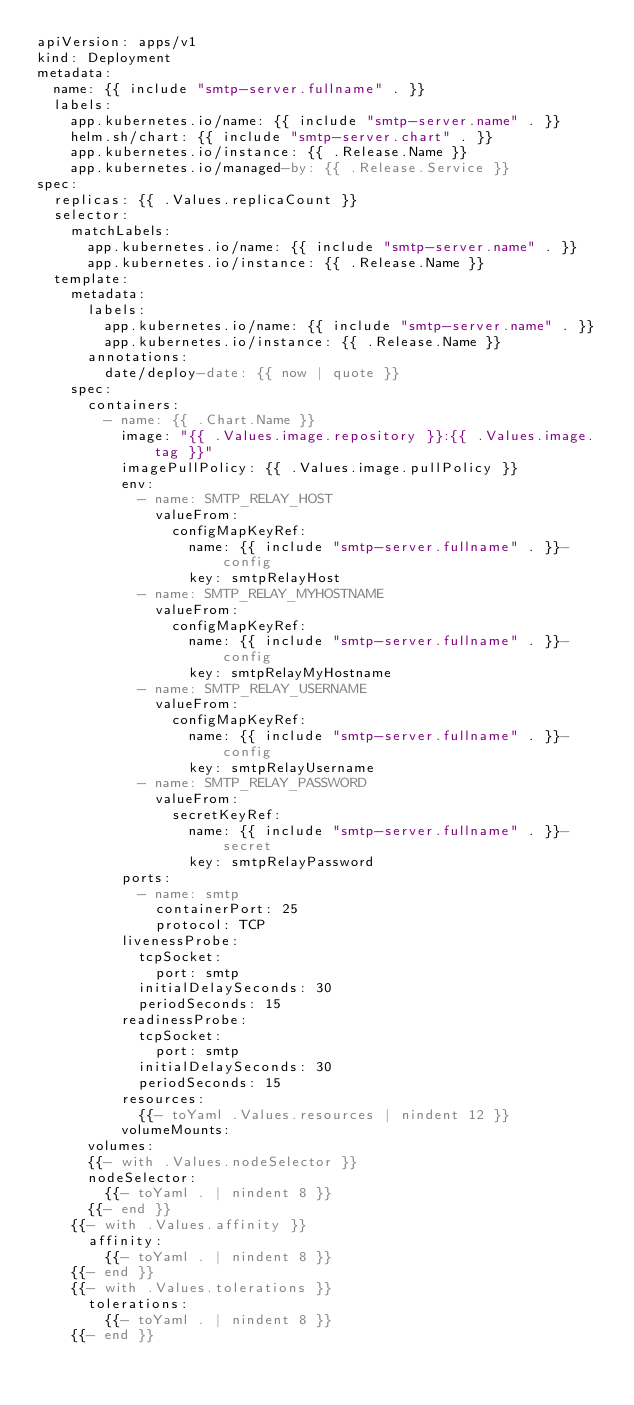<code> <loc_0><loc_0><loc_500><loc_500><_YAML_>apiVersion: apps/v1
kind: Deployment
metadata:
  name: {{ include "smtp-server.fullname" . }}
  labels:
    app.kubernetes.io/name: {{ include "smtp-server.name" . }}
    helm.sh/chart: {{ include "smtp-server.chart" . }}
    app.kubernetes.io/instance: {{ .Release.Name }}
    app.kubernetes.io/managed-by: {{ .Release.Service }}
spec:
  replicas: {{ .Values.replicaCount }}
  selector:
    matchLabels:
      app.kubernetes.io/name: {{ include "smtp-server.name" . }}
      app.kubernetes.io/instance: {{ .Release.Name }}
  template:
    metadata:
      labels:
        app.kubernetes.io/name: {{ include "smtp-server.name" . }}
        app.kubernetes.io/instance: {{ .Release.Name }}
      annotations:
        date/deploy-date: {{ now | quote }}
    spec:
      containers:
        - name: {{ .Chart.Name }}
          image: "{{ .Values.image.repository }}:{{ .Values.image.tag }}"
          imagePullPolicy: {{ .Values.image.pullPolicy }}
          env:
            - name: SMTP_RELAY_HOST
              valueFrom:
                configMapKeyRef:
                  name: {{ include "smtp-server.fullname" . }}-config
                  key: smtpRelayHost
            - name: SMTP_RELAY_MYHOSTNAME
              valueFrom:
                configMapKeyRef:
                  name: {{ include "smtp-server.fullname" . }}-config
                  key: smtpRelayMyHostname
            - name: SMTP_RELAY_USERNAME
              valueFrom:
                configMapKeyRef:
                  name: {{ include "smtp-server.fullname" . }}-config
                  key: smtpRelayUsername
            - name: SMTP_RELAY_PASSWORD
              valueFrom:
                secretKeyRef:
                  name: {{ include "smtp-server.fullname" . }}-secret
                  key: smtpRelayPassword
          ports:
            - name: smtp
              containerPort: 25
              protocol: TCP
          livenessProbe:
            tcpSocket:
              port: smtp
            initialDelaySeconds: 30
            periodSeconds: 15
          readinessProbe:
            tcpSocket:
              port: smtp
            initialDelaySeconds: 30
            periodSeconds: 15
          resources:
            {{- toYaml .Values.resources | nindent 12 }}
          volumeMounts:
      volumes:
      {{- with .Values.nodeSelector }}
      nodeSelector:
        {{- toYaml . | nindent 8 }}
      {{- end }}
    {{- with .Values.affinity }}
      affinity:
        {{- toYaml . | nindent 8 }}
    {{- end }}
    {{- with .Values.tolerations }}
      tolerations:
        {{- toYaml . | nindent 8 }}
    {{- end }}
</code> 